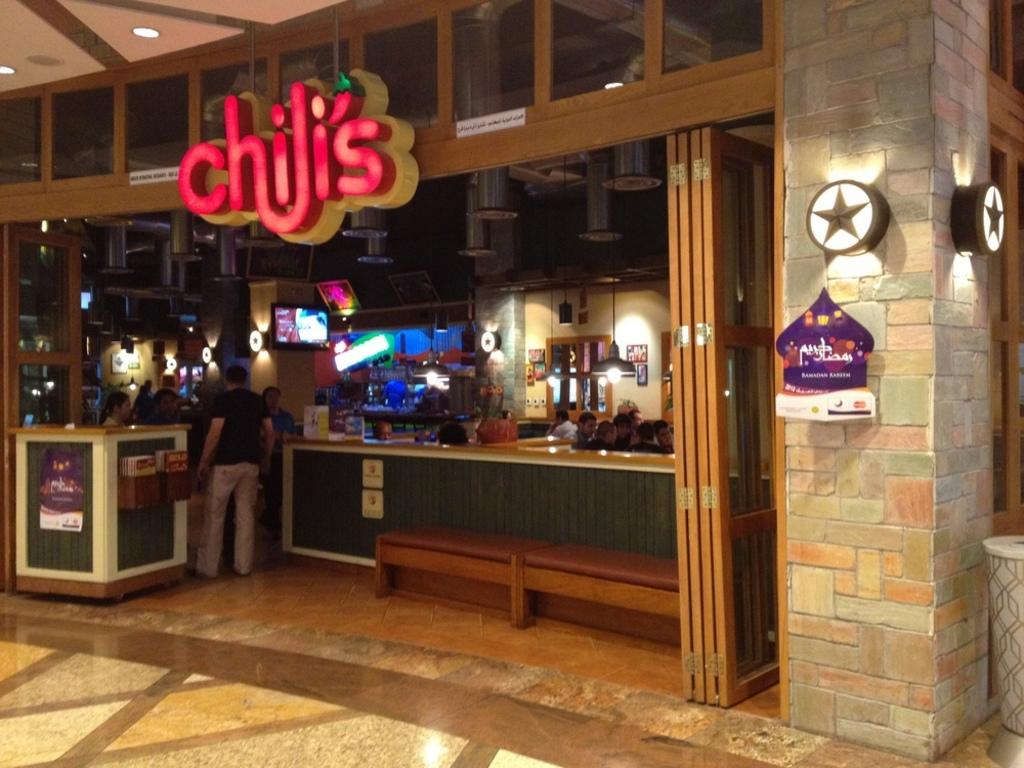What type of establishment is shown in the image? There is a restaurant in the image. How can the restaurant be identified? The restaurant has a name board. What are the people in the image doing? There are people sitting and standing in the image. What can be seen in terms of lighting in the image? There are lights visible in the image. What type of material is used for some objects in the image? There are wooden objects in the image. Can you tell me how many pencils are lying on the wooden table in the image? There are no pencils present in the image; it features a restaurant with people sitting and standing. What type of coast is visible in the image? There is no coast visible in the image; it is a restaurant scene with people and wooden objects. 